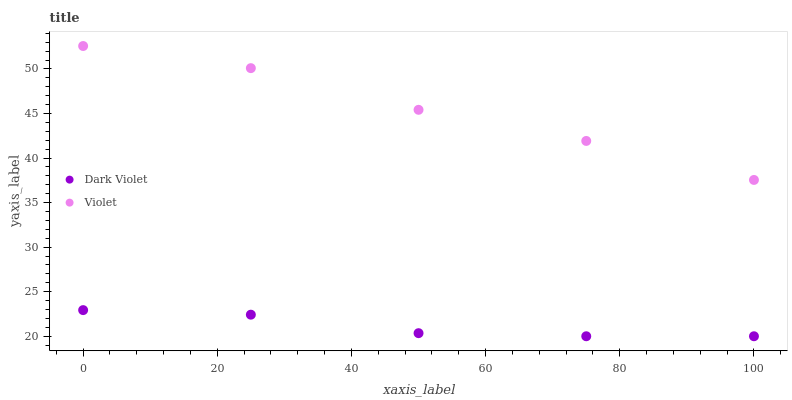Does Dark Violet have the minimum area under the curve?
Answer yes or no. Yes. Does Violet have the maximum area under the curve?
Answer yes or no. Yes. Does Violet have the minimum area under the curve?
Answer yes or no. No. Is Dark Violet the smoothest?
Answer yes or no. Yes. Is Violet the roughest?
Answer yes or no. Yes. Is Violet the smoothest?
Answer yes or no. No. Does Dark Violet have the lowest value?
Answer yes or no. Yes. Does Violet have the lowest value?
Answer yes or no. No. Does Violet have the highest value?
Answer yes or no. Yes. Is Dark Violet less than Violet?
Answer yes or no. Yes. Is Violet greater than Dark Violet?
Answer yes or no. Yes. Does Dark Violet intersect Violet?
Answer yes or no. No. 